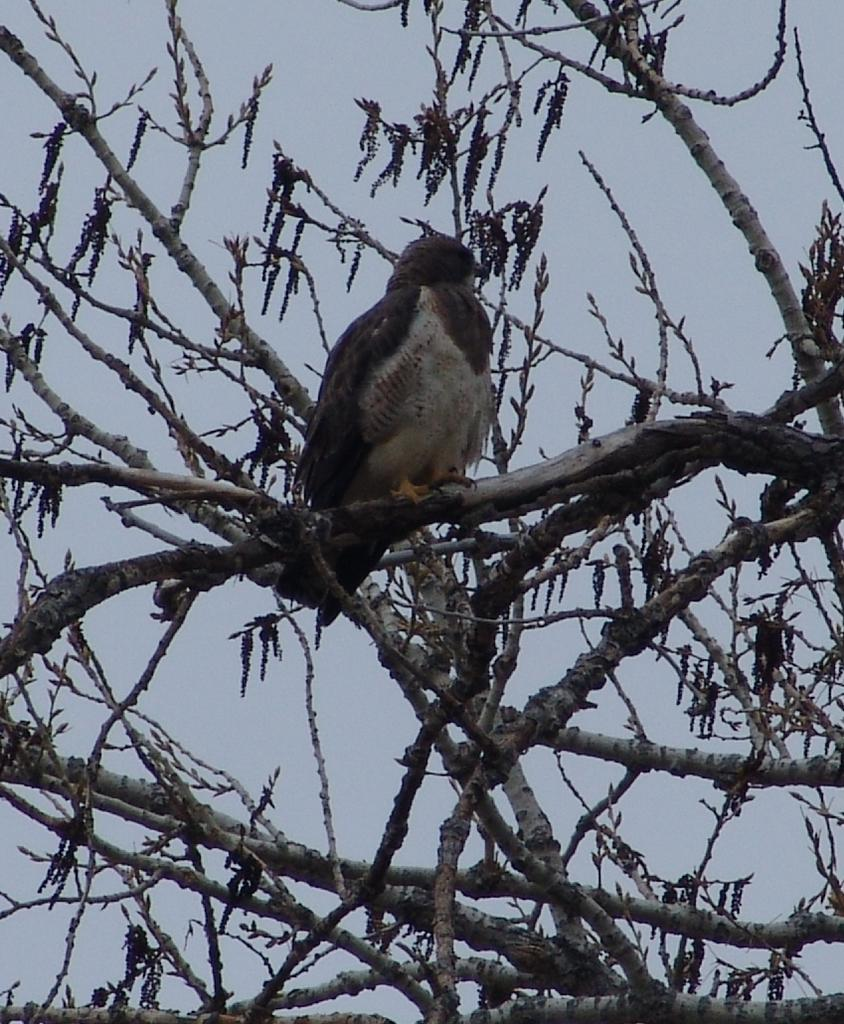What type of animal can be seen in the image? There is a bird in the image. What is the condition of the tree in the image? There is a dried tree in the image. What part of the natural environment is visible in the image? The sky is visible in the image. What type of wine is being served in the image? There is no wine present in the image; it features a bird and a dried tree. What kind of string can be seen tied around the bird's leg in the image? There is no string tied around the bird's leg in the image; it only shows a bird and a dried tree. 